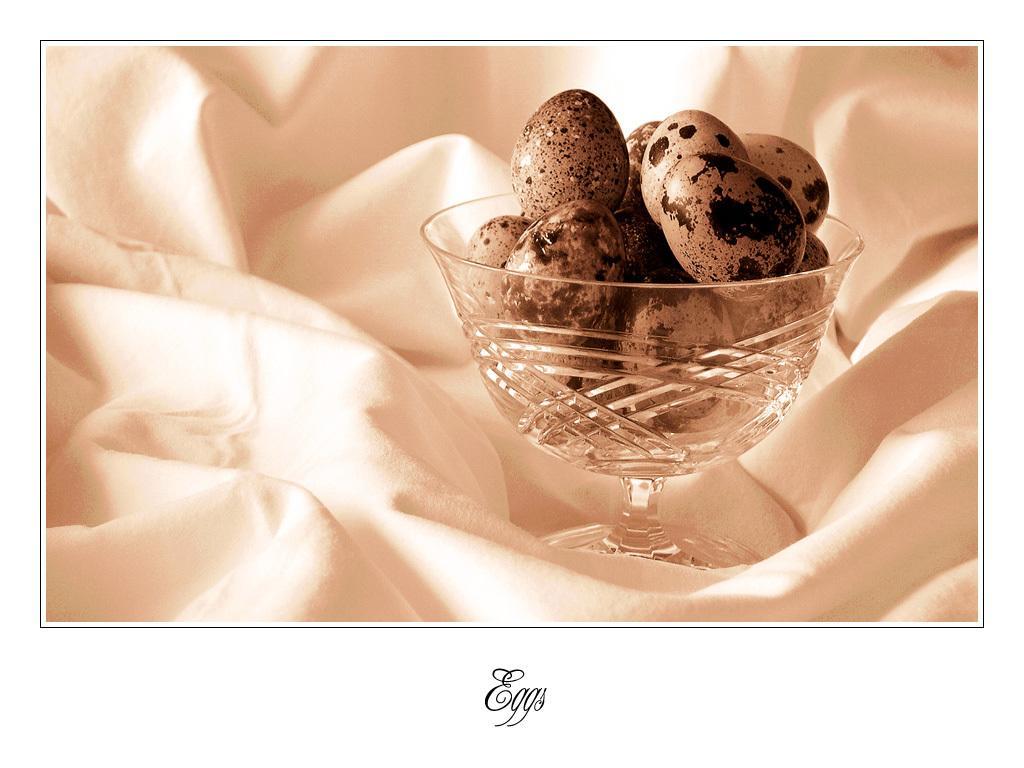Could you give a brief overview of what you see in this image? In this image there is a bowl, eggs and white cloth. Eggs are in a bowl. Bowl is kept on the white cloth. Something is written at the bottom of the image. 